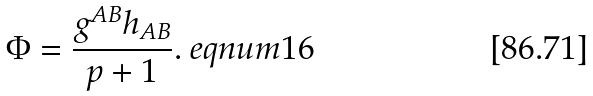Convert formula to latex. <formula><loc_0><loc_0><loc_500><loc_500>\Phi = \frac { g ^ { A B } h _ { A B } } { p + 1 } . \ e q n u m { 1 6 }</formula> 